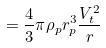Convert formula to latex. <formula><loc_0><loc_0><loc_500><loc_500>= \frac { 4 } { 3 } \pi \rho _ { p } r _ { p } ^ { 3 } \frac { V _ { t } ^ { 2 } } { r }</formula> 